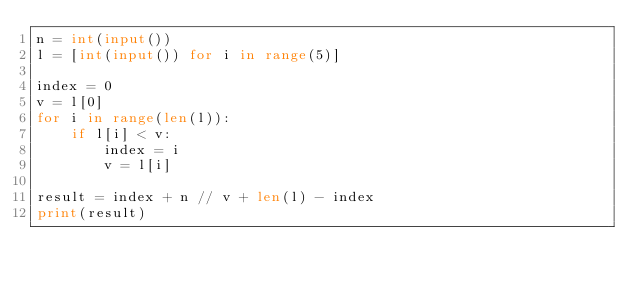Convert code to text. <code><loc_0><loc_0><loc_500><loc_500><_Python_>n = int(input())
l = [int(input()) for i in range(5)]

index = 0
v = l[0]
for i in range(len(l)):
    if l[i] < v:
        index = i
        v = l[i]

result = index + n // v + len(l) - index
print(result)
</code> 